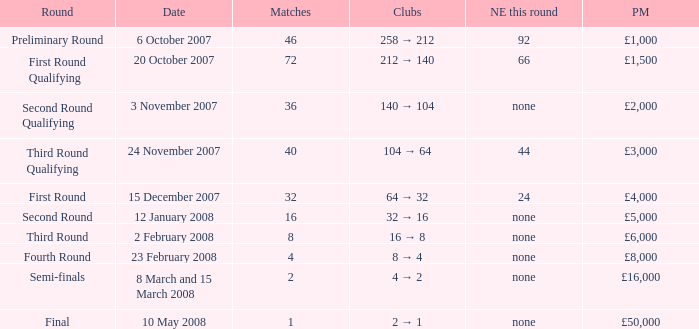How many new entries this round are there with more than 16 matches and a third round qualifying? 44.0. 